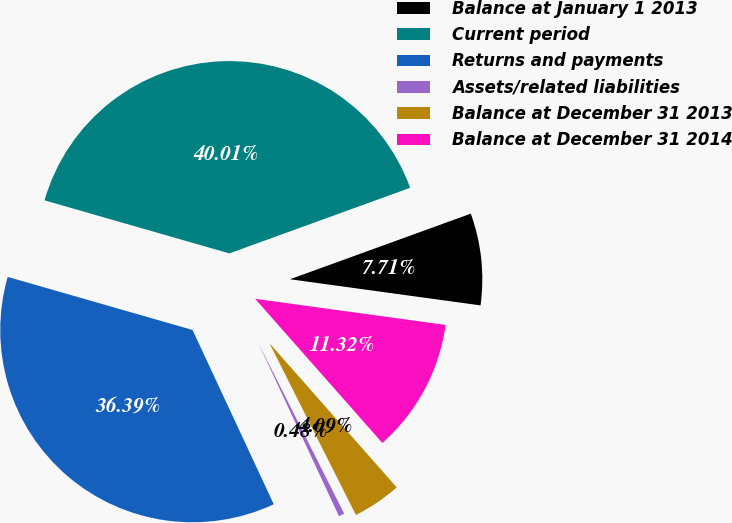<chart> <loc_0><loc_0><loc_500><loc_500><pie_chart><fcel>Balance at January 1 2013<fcel>Current period<fcel>Returns and payments<fcel>Assets/related liabilities<fcel>Balance at December 31 2013<fcel>Balance at December 31 2014<nl><fcel>7.71%<fcel>40.01%<fcel>36.39%<fcel>0.48%<fcel>4.09%<fcel>11.32%<nl></chart> 